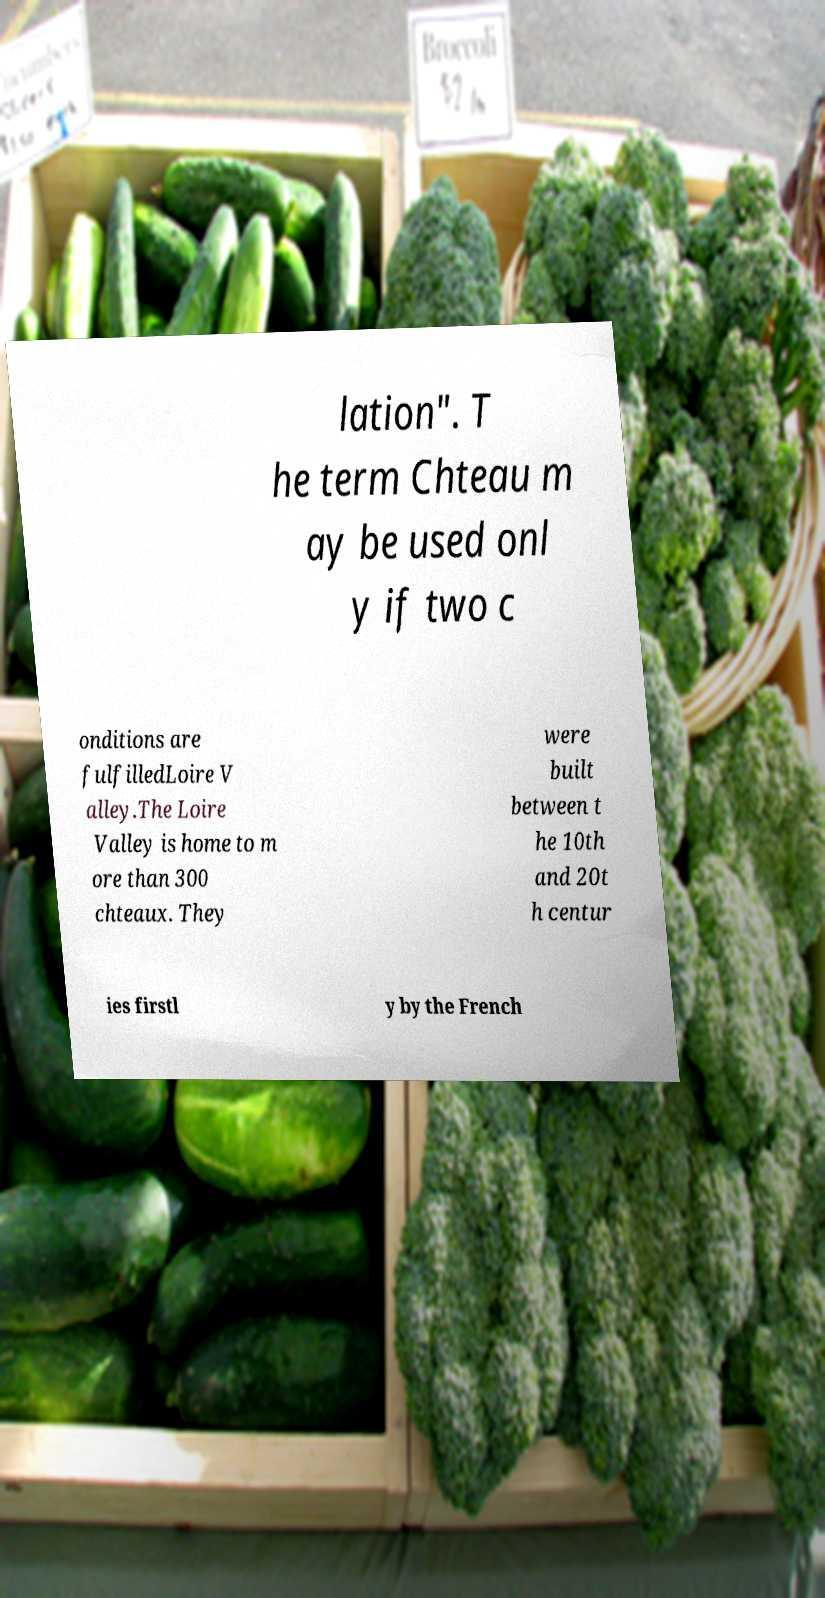Can you accurately transcribe the text from the provided image for me? lation". T he term Chteau m ay be used onl y if two c onditions are fulfilledLoire V alley.The Loire Valley is home to m ore than 300 chteaux. They were built between t he 10th and 20t h centur ies firstl y by the French 